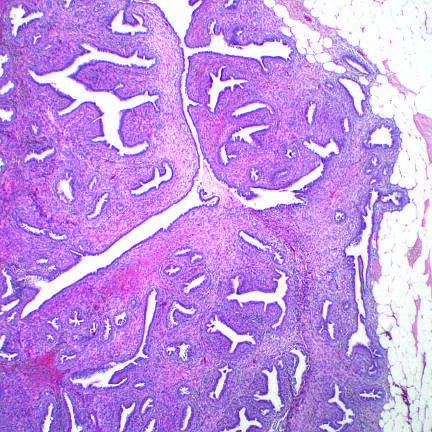do carcinoid tumors distort the glandular tissue, forming cleftlike spaces, and bulge into surrounding stroma?
Answer the question using a single word or phrase. No 